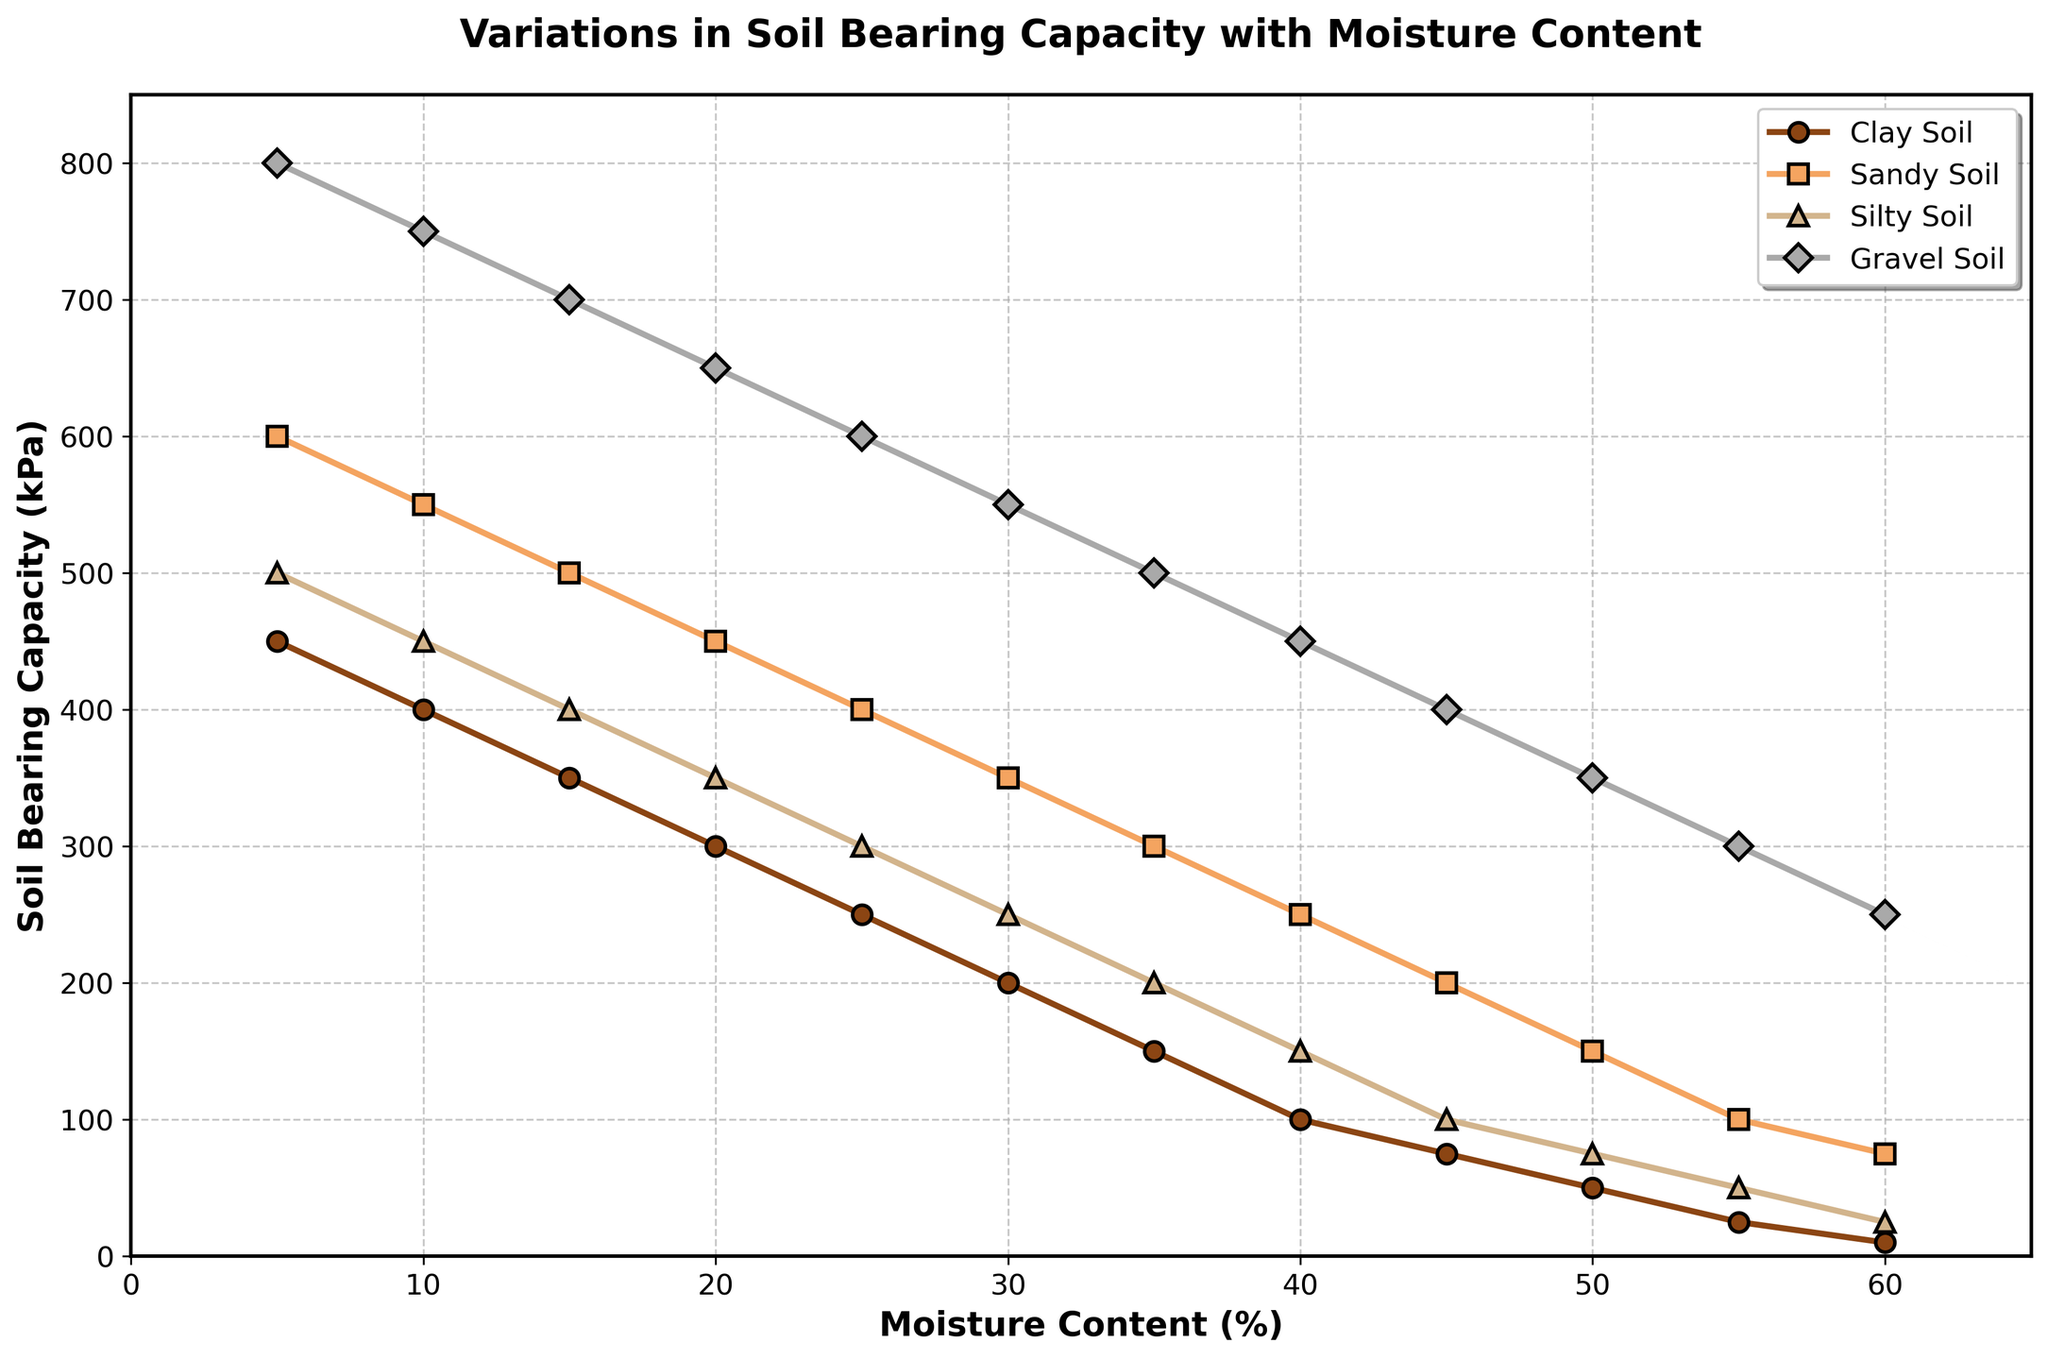What happens to the bearing capacity of clay soil as the moisture content increases? As the moisture content increases from 5% to 60%, the bearing capacity of clay soil decreases steadily from 450 kPa to 10 kPa, indicating that moisture negatively affects clay soil's bearing capacity.
Answer: It decreases Which soil type has the highest bearing capacity at 10% moisture content? At 10% moisture content, gravel soil has the highest bearing capacity at 750 kPa, compared to clay (400 kPa), sandy (550 kPa), and silty soil (450 kPa).
Answer: Gravel soil Compare the bearing capacities of sandy soil and silty soil at 35% moisture content. At 35% moisture content, sandy soil has a bearing capacity of 300 kPa, while silty soil has a bearing capacity of 200 kPa. Sandy soil has a higher bearing capacity by 100 kPa.
Answer: Sandy soil is higher by 100 kPa At what moisture content do all soil types exhibit a bearing capacity below 100 kPa? By inspecting the graph, it can be seen that all soil types exhibit a bearing capacity below 100 kPa at around 55% moisture content.
Answer: 55% How does the bearing capacity of gravel soil change between 15% and 25% moisture content? Gravel soil's bearing capacity decreases from 700 kPa at 15% moisture content to 600 kPa at 25% moisture content, indicating a reduction of 100 kPa.
Answer: It decreases by 100 kPa Which soil type shows the steepest decline in bearing capacity with increasing moisture content? By observing the slopes of the lines, clay soil shows the steepest decline in bearing capacity with increasing moisture content, dropping from 450 kPa to 10 kPa between 5% and 60% moisture content.
Answer: Clay soil What is the average bearing capacity of silty soil at moisture contents of 20%, 30%, and 40%? First, identify the bearing capacities at these moisture contents: 350 kPa, 250 kPa, and 150 kPa respectively. The sum is 350 + 250 + 150 = 750 kPa. The average is 750 / 3.
Answer: 250 kPa Determine the difference in bearing capacities of gravel soil between 10% and 40% moisture content. At 10% moisture content, gravel soil has a bearing capacity of 750 kPa, and at 40% moisture content, it has 450 kPa. The difference is 750 - 450 = 300 kPa.
Answer: 300 kPa Which soil type maintains a bearing capacity above 200 kPa for the longest range of moisture content? Gravel soil maintains a bearing capacity above 200 kPa from 5% to 50% moisture content, a range of 45%, which is longer compared to other soil types.
Answer: Gravel soil At what moisture content does clay soil's bearing capacity fall below 100 kPa? By examining the graph, clay soil's bearing capacity falls below 100 kPa at 40% moisture content.
Answer: 40% 